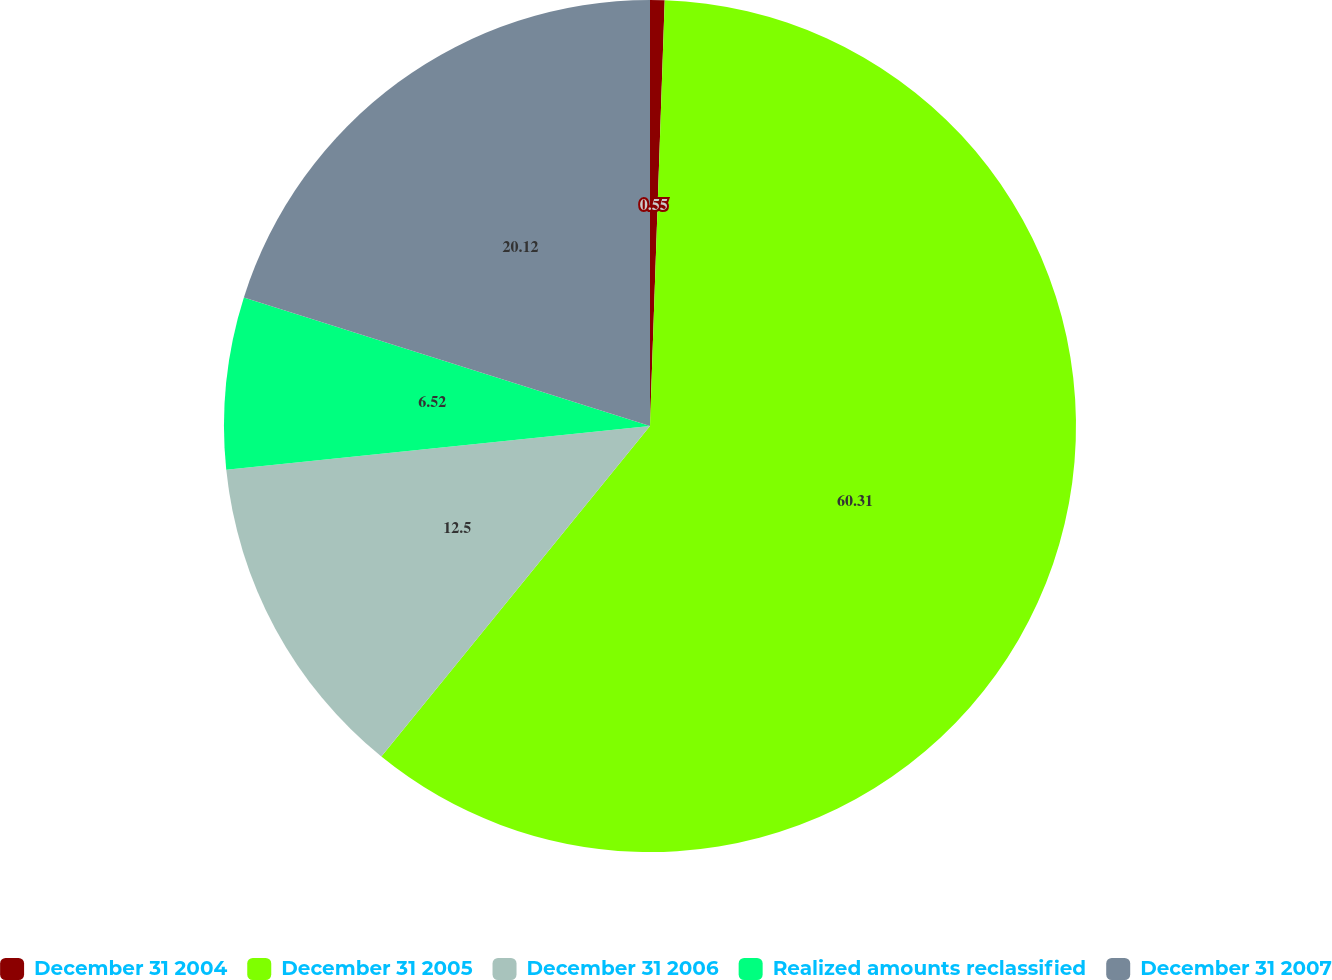Convert chart to OTSL. <chart><loc_0><loc_0><loc_500><loc_500><pie_chart><fcel>December 31 2004<fcel>December 31 2005<fcel>December 31 2006<fcel>Realized amounts reclassified<fcel>December 31 2007<nl><fcel>0.55%<fcel>60.31%<fcel>12.5%<fcel>6.52%<fcel>20.12%<nl></chart> 